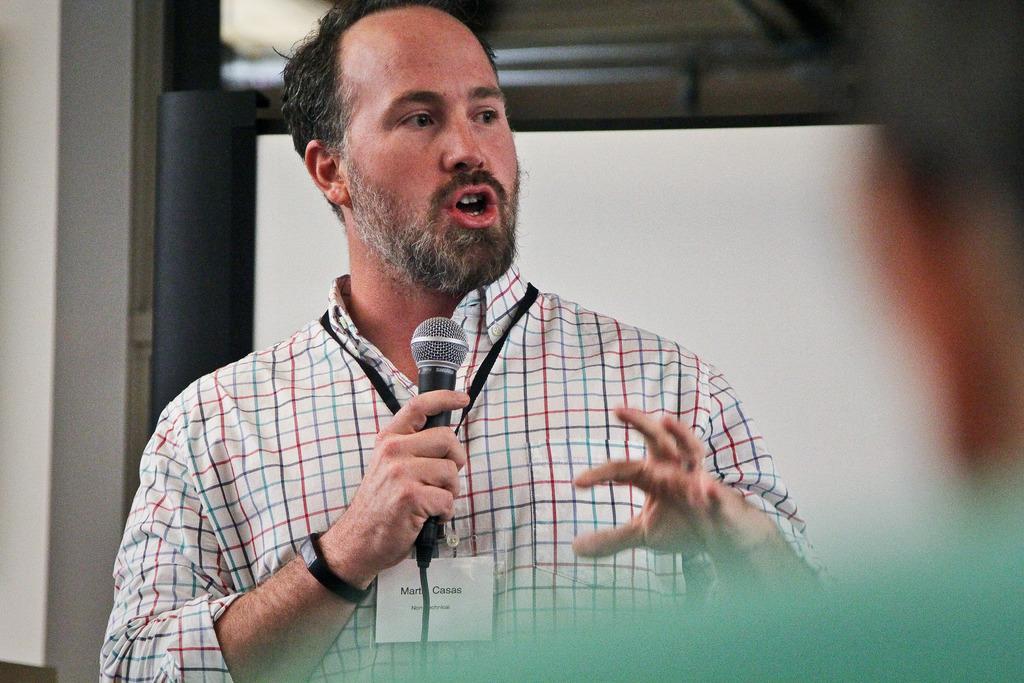In one or two sentences, can you explain what this image depicts? In this picture we can see a man who is holding a mike with his hand. And he wear a id card. 